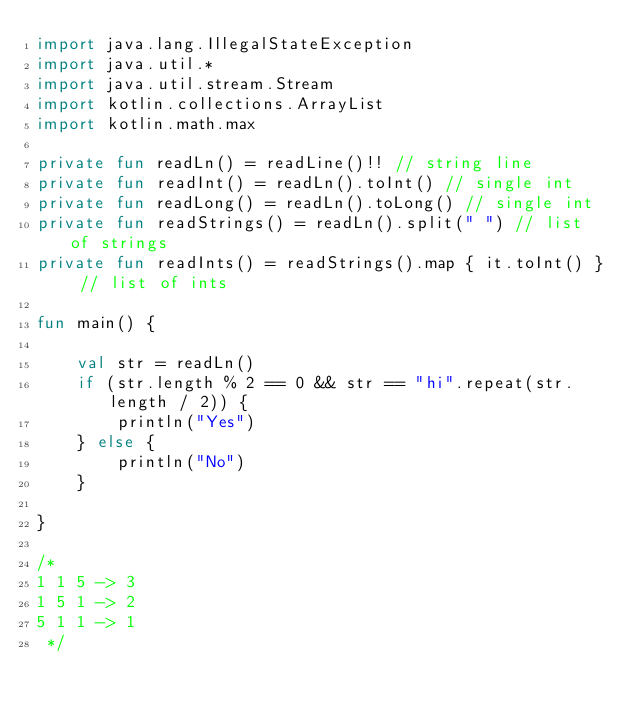Convert code to text. <code><loc_0><loc_0><loc_500><loc_500><_Kotlin_>import java.lang.IllegalStateException
import java.util.*
import java.util.stream.Stream
import kotlin.collections.ArrayList
import kotlin.math.max

private fun readLn() = readLine()!! // string line
private fun readInt() = readLn().toInt() // single int
private fun readLong() = readLn().toLong() // single int
private fun readStrings() = readLn().split(" ") // list of strings
private fun readInts() = readStrings().map { it.toInt() } // list of ints

fun main() {

    val str = readLn()
    if (str.length % 2 == 0 && str == "hi".repeat(str.length / 2)) {
        println("Yes")
    } else {
        println("No")
    }

}

/*
1 1 5 -> 3
1 5 1 -> 2
5 1 1 -> 1
 */
</code> 